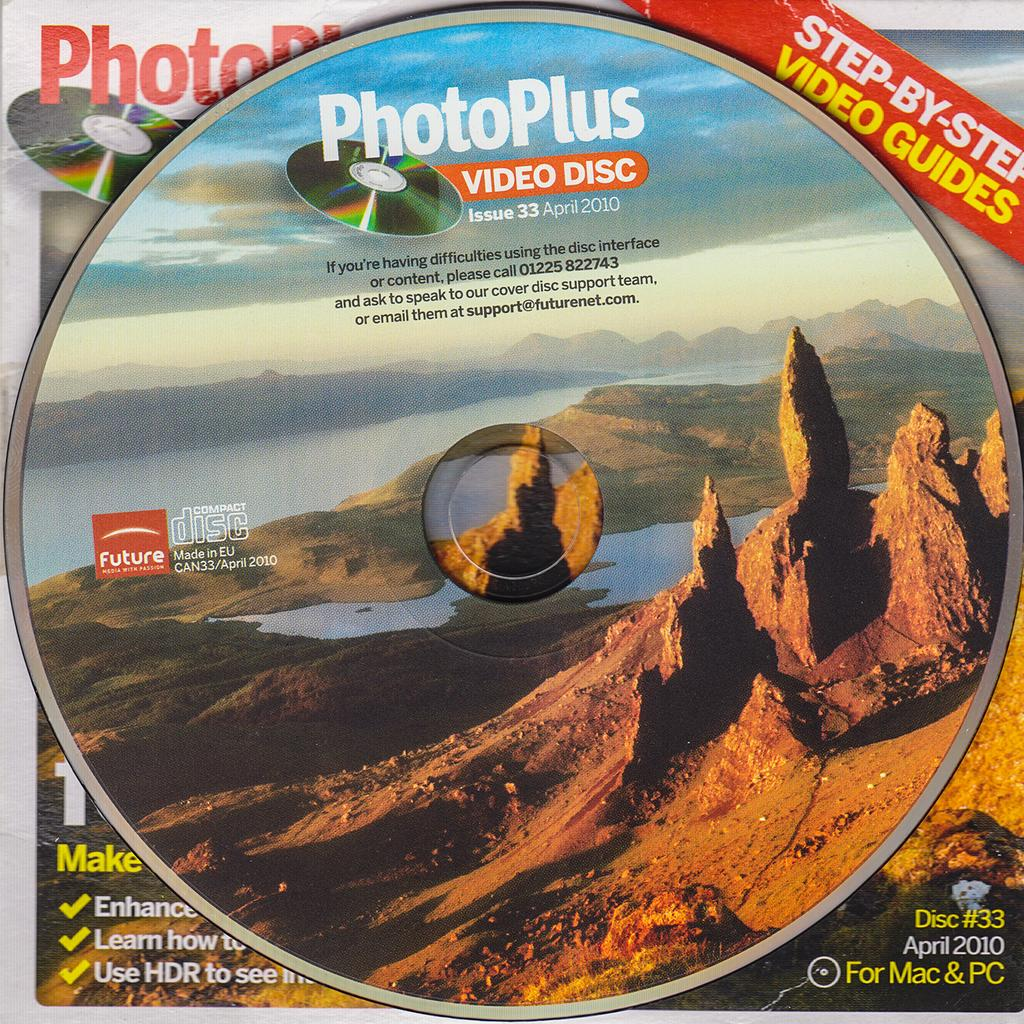Provide a one-sentence caption for the provided image. A PhotoPlus Video Disc features an Arizona mountain scene, complete with mountains and a lake. 